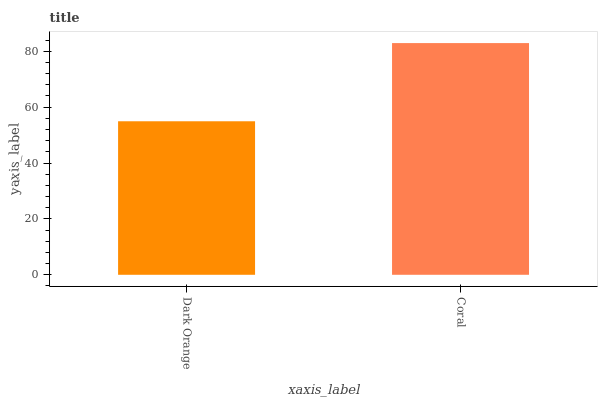Is Dark Orange the minimum?
Answer yes or no. Yes. Is Coral the maximum?
Answer yes or no. Yes. Is Coral the minimum?
Answer yes or no. No. Is Coral greater than Dark Orange?
Answer yes or no. Yes. Is Dark Orange less than Coral?
Answer yes or no. Yes. Is Dark Orange greater than Coral?
Answer yes or no. No. Is Coral less than Dark Orange?
Answer yes or no. No. Is Coral the high median?
Answer yes or no. Yes. Is Dark Orange the low median?
Answer yes or no. Yes. Is Dark Orange the high median?
Answer yes or no. No. Is Coral the low median?
Answer yes or no. No. 